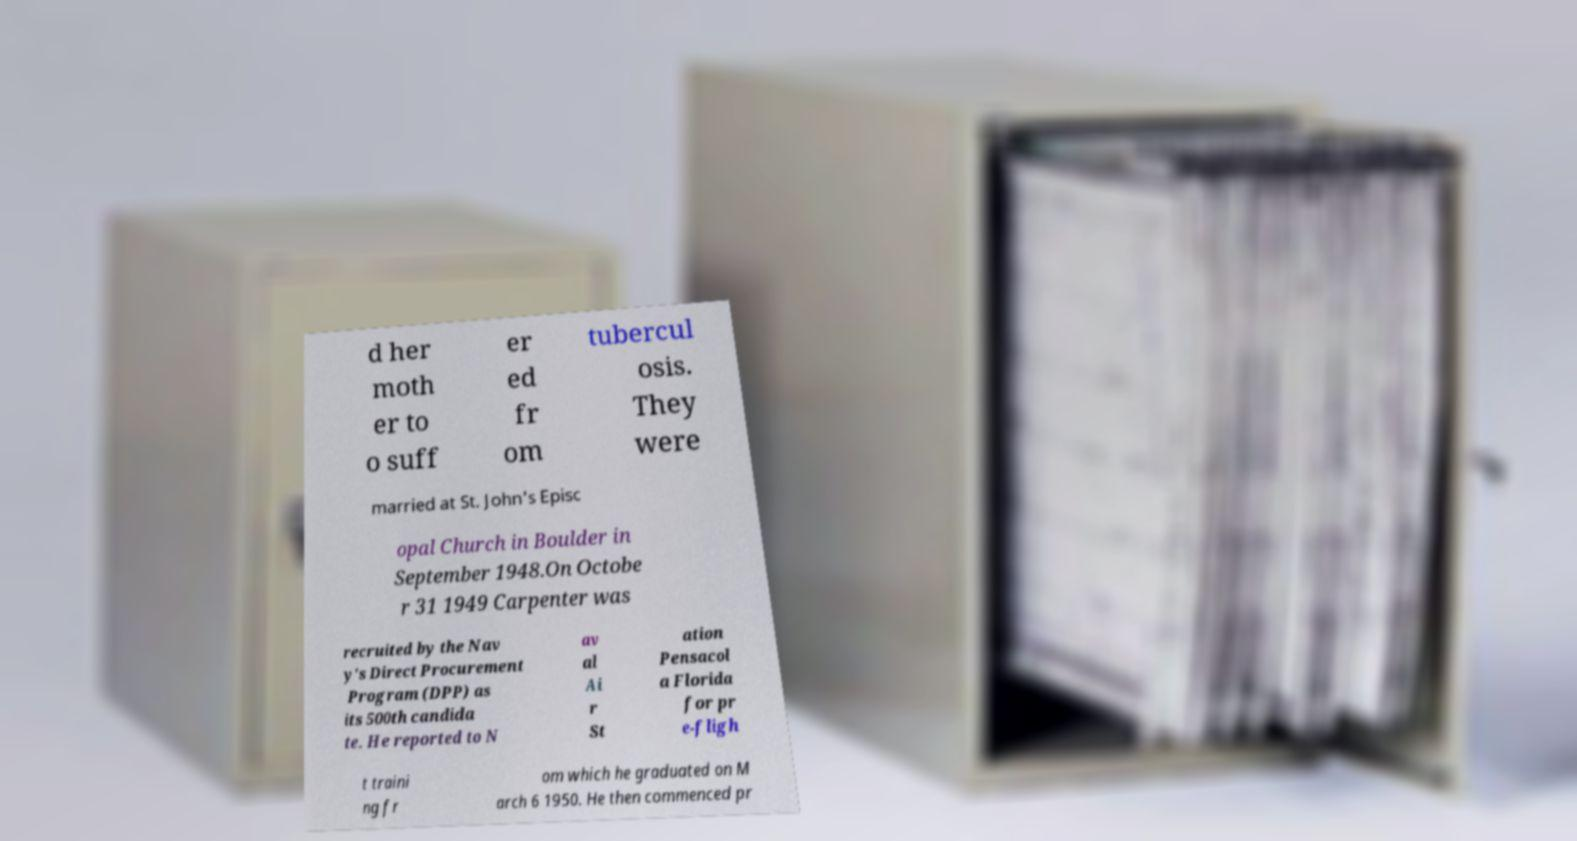Please read and relay the text visible in this image. What does it say? d her moth er to o suff er ed fr om tubercul osis. They were married at St. John's Episc opal Church in Boulder in September 1948.On Octobe r 31 1949 Carpenter was recruited by the Nav y's Direct Procurement Program (DPP) as its 500th candida te. He reported to N av al Ai r St ation Pensacol a Florida for pr e-fligh t traini ng fr om which he graduated on M arch 6 1950. He then commenced pr 